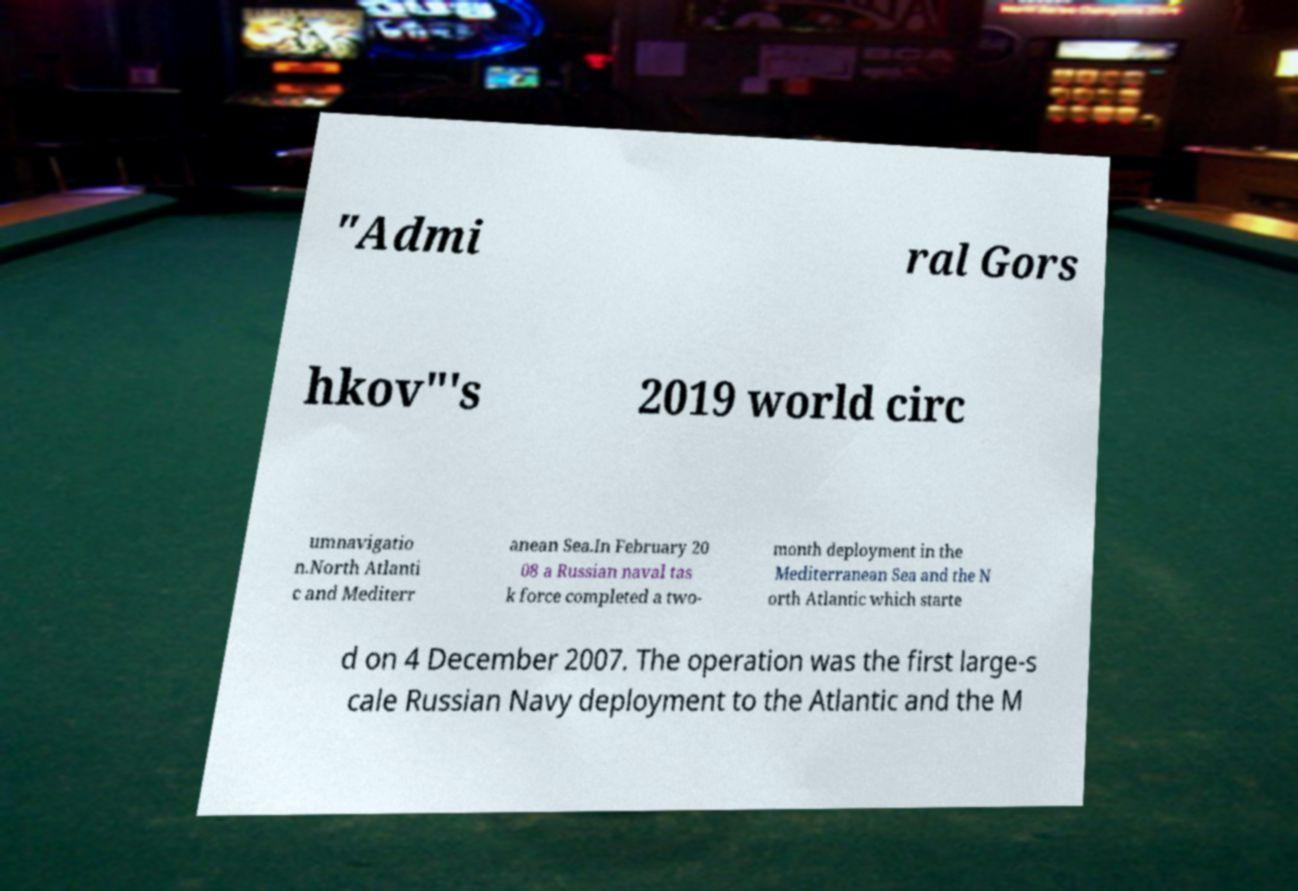Please read and relay the text visible in this image. What does it say? "Admi ral Gors hkov"'s 2019 world circ umnavigatio n.North Atlanti c and Mediterr anean Sea.In February 20 08 a Russian naval tas k force completed a two- month deployment in the Mediterranean Sea and the N orth Atlantic which starte d on 4 December 2007. The operation was the first large-s cale Russian Navy deployment to the Atlantic and the M 